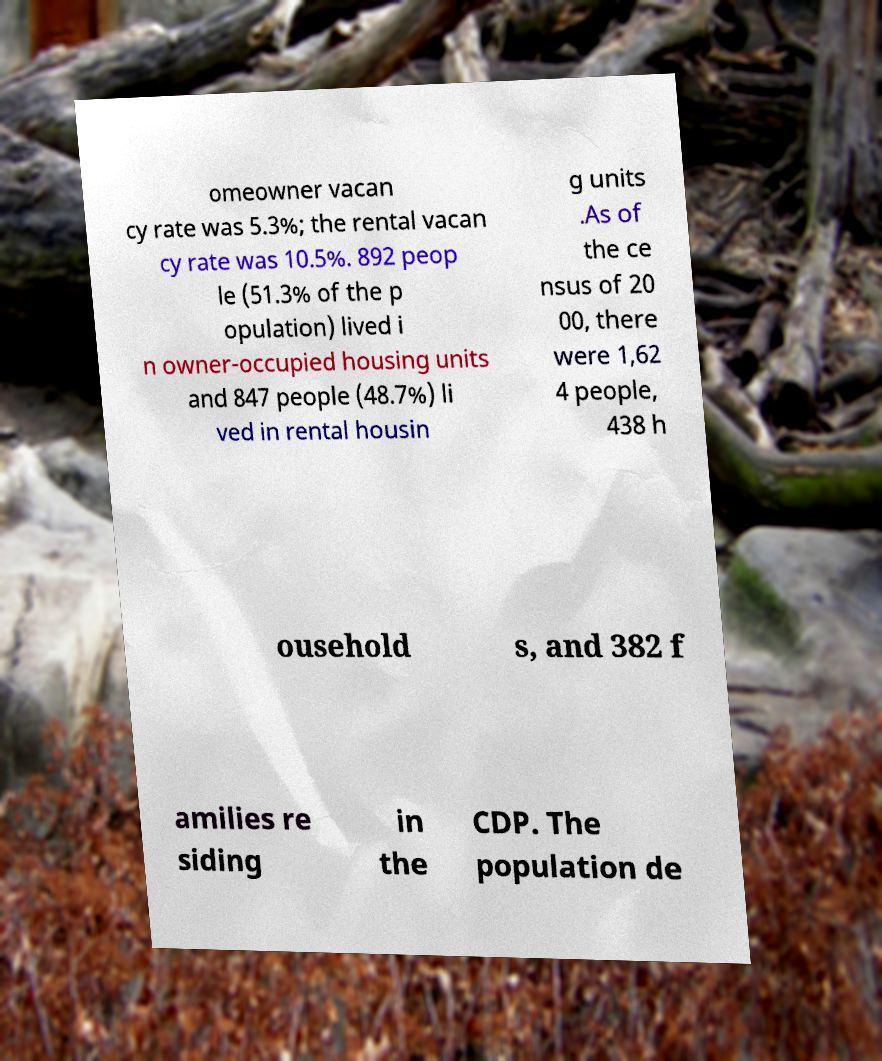I need the written content from this picture converted into text. Can you do that? omeowner vacan cy rate was 5.3%; the rental vacan cy rate was 10.5%. 892 peop le (51.3% of the p opulation) lived i n owner-occupied housing units and 847 people (48.7%) li ved in rental housin g units .As of the ce nsus of 20 00, there were 1,62 4 people, 438 h ousehold s, and 382 f amilies re siding in the CDP. The population de 